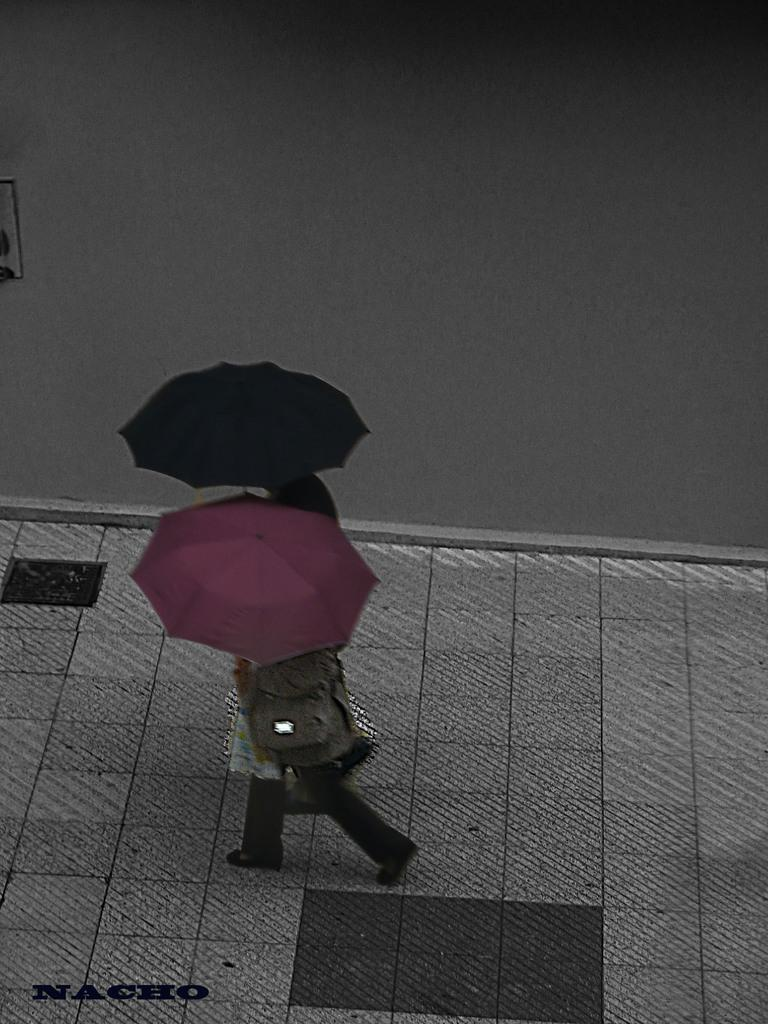How many people are in the image? There are two persons in the image. What are the persons doing in the image? The persons are walking. What are the persons holding while walking? The persons are holding umbrellas. What can be seen in the background of the image? There is a wall in the background of the image. Can you tell me how many cherries are on the persons' heads in the image? There are no cherries present on the persons' heads in the image. What type of print can be seen on the persons' clothing in the image? There is no information about the persons' clothing or any prints in the image. 